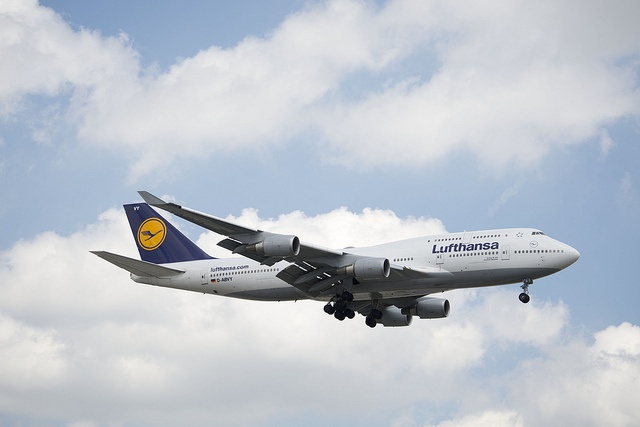Describe the objects in this image and their specific colors. I can see a airplane in lightgray, black, gray, and darkgray tones in this image. 